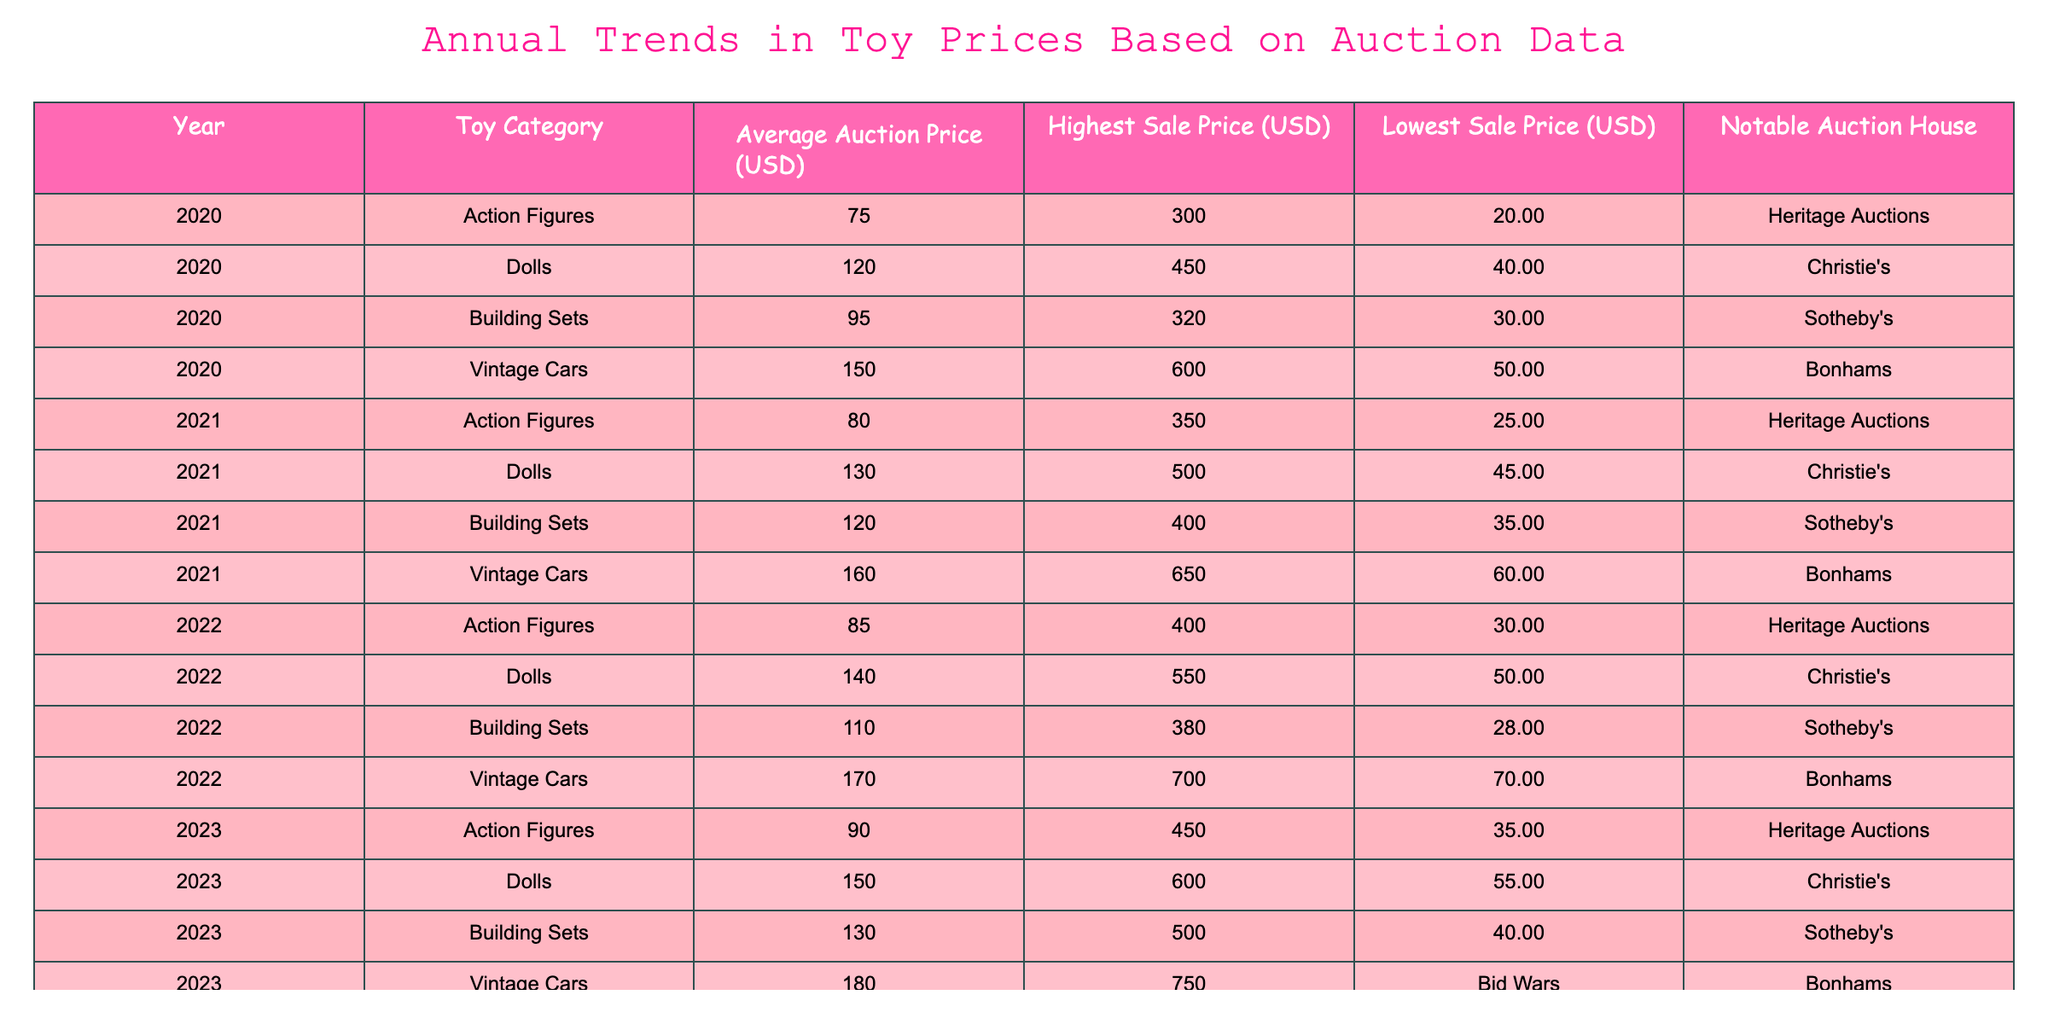What was the highest sale price for Vintage Cars in 2022? Referring to the Vintage Cars row in 2022, the highest sale price listed is 700 USD.
Answer: 700 USD What is the average auction price of Dolls over the years 2020 to 2023? To find the average auction price of Dolls, sum the average prices from 2020 (120), 2021 (130), 2022 (140), and 2023 (150), which totals 540. Then divide by the number of years (4), resulting in an average of 135.
Answer: 135 Did Action Figures have a higher average auction price in 2023 compared to 2020? The average auction price for Action Figures in 2020 was 75 USD and in 2023 it was 90 USD. Since 90 is greater than 75, the statement is true.
Answer: Yes What was the overall trend in average auction prices for Building Sets from 2020 to 2023? The average auction prices for Building Sets are 95 in 2020, 120 in 2021, 110 in 2022, and 130 in 2023. This shows that the prices increase from 2020 to 2021, decrease in 2022, and then increase again in 2023. Thus, the overall trend fluctuated with increases and decreases.
Answer: Fluctuating trend Which toy category had the lowest average auction price in 2021? Checking the average auction prices for 2021: Action Figures (80), Dolls (130), Building Sets (120), and Vintage Cars (160). The lowest average price is for Action Figures.
Answer: Action Figures 